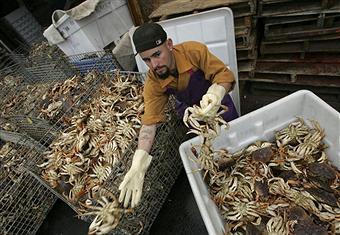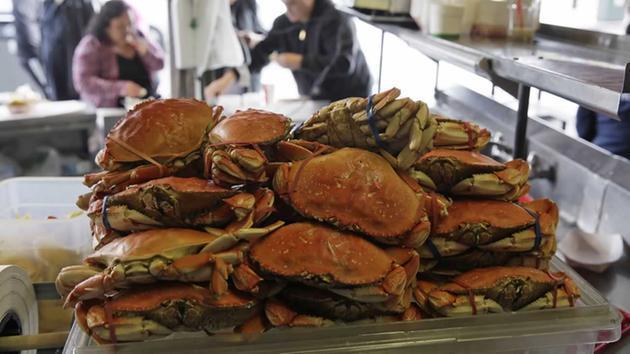The first image is the image on the left, the second image is the image on the right. Given the left and right images, does the statement "In at least one image, the crabs have a blue tint near the claws." hold true? Answer yes or no. No. The first image is the image on the left, the second image is the image on the right. Given the left and right images, does the statement "Crabs are being dumped out of a container." hold true? Answer yes or no. No. 